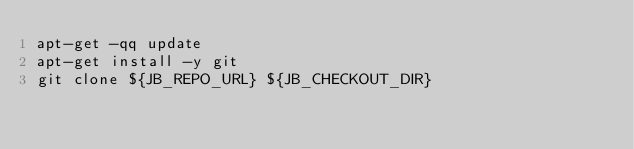<code> <loc_0><loc_0><loc_500><loc_500><_Bash_>apt-get -qq update
apt-get install -y git
git clone ${JB_REPO_URL} ${JB_CHECKOUT_DIR}
</code> 